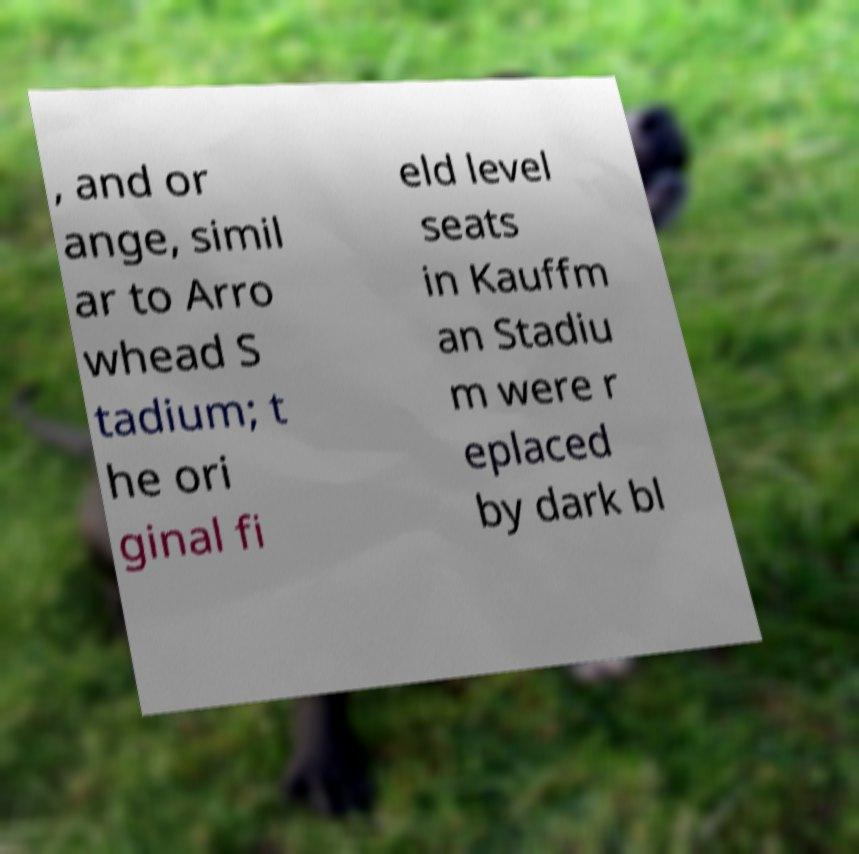Can you read and provide the text displayed in the image?This photo seems to have some interesting text. Can you extract and type it out for me? , and or ange, simil ar to Arro whead S tadium; t he ori ginal fi eld level seats in Kauffm an Stadiu m were r eplaced by dark bl 